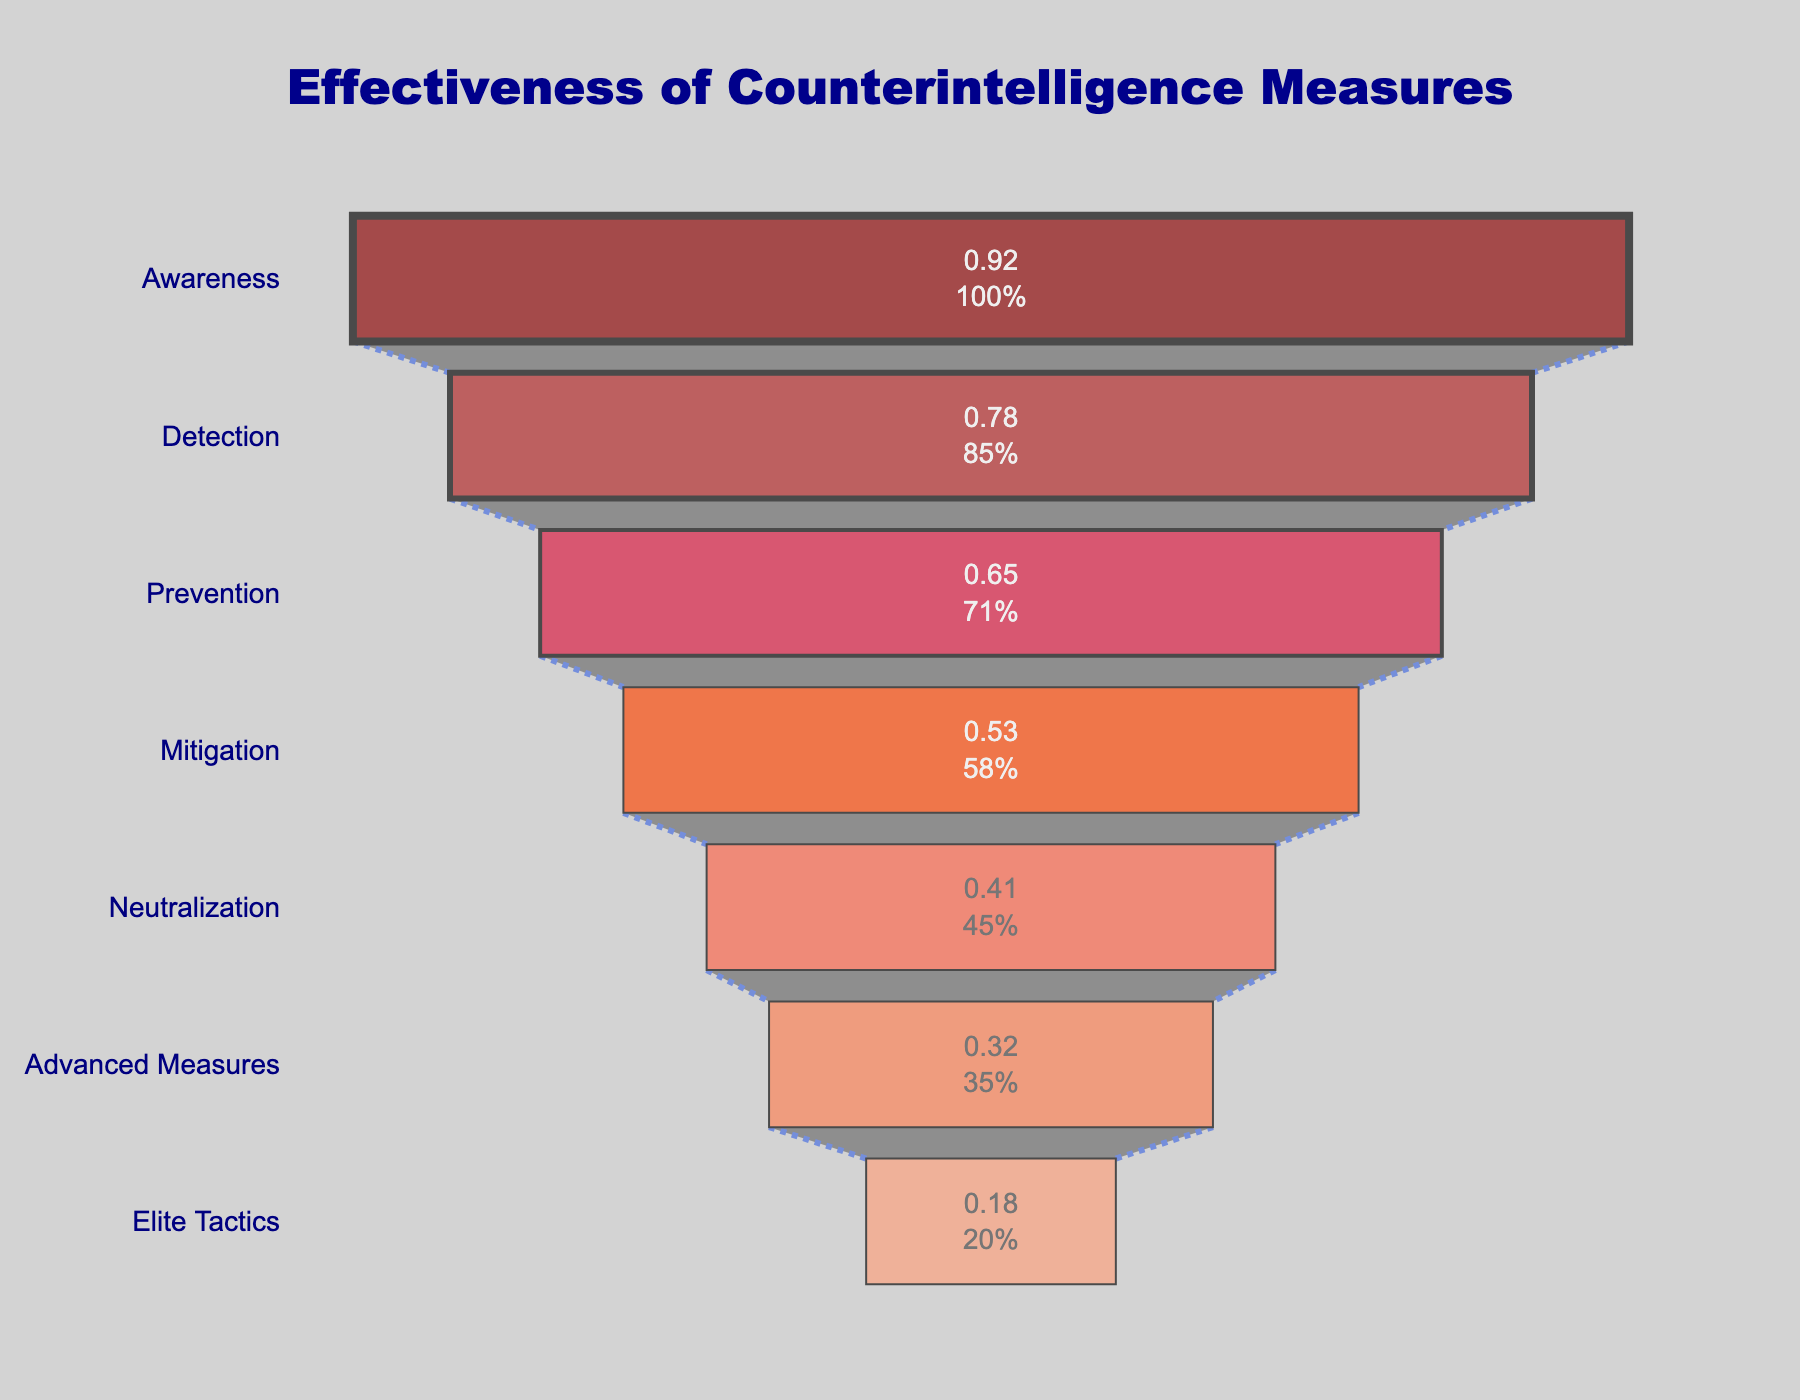What's the title of the figure? The title is the text at the top of the figure, which summarizes what the figure is about. Titles are often positioned centrally at the top of the chart.
Answer: Effectiveness of Counterintelligence Measures Which counterintelligence measure has the lowest effectiveness rate? The effectiveness rate is shown on the horizontal axis, and the one with the smallest value corresponds to the lowest effectiveness. Look for the smallest percentage on the funnel.
Answer: Deep Cover Penetration How many stages are shown in the funnel chart? Count the distinct stages listed on the vertical axis from the top to the bottom of the funnel.
Answer: Seven What is the effectiveness rate of Secure Communication Protocols? Identify the stage labeled "Secure Communication Protocols" and read the effectiveness rate corresponding to it.
Answer: 65% How does the effectiveness rate of Counterintelligence Polygraphs compare to Surveillance Detection Routes? Find the effectiveness rates for both stages and then compare them directly. The rate of Counterintelligence Polygraphs is 53%, and for Surveillance Detection Routes, it is 78%.
Answer: Surveillance Detection Routes have a higher rate What's the average effectiveness rate of the first three stages in the funnel? Identify the effectiveness rates of the first three stages: 92%, 78%, and 65%. Then calculate the average: (92 + 78 + 65)/3.
Answer: 78.33% Which stage shows the largest drop in effectiveness from the previous stage? For each stage, subtract the effectiveness rate of the next stage from its own effectiveness rate. The stage with the largest difference shows the largest drop.
Answer: Secure Communication Protocols to Counterintelligence Polygraphs What can you infer from the color coding of the stages in the funnel? Each stage has a unique color, which helps differentiate them visually. Additionally, the colors might suggest a gradient from most to least effectiveness.
Answer: Colors range from dark red to light peach, indicating decreasing effectiveness What proportion of the initial effectiveness rate does the Mitigation stage have? The initial effectiveness rate is 92%. The Mitigation stage has a 53% effectiveness rate. Divide 53 by 92 and multiply by 100 to get the proportion.
Answer: 57.6% Which two stages show the closest effectiveness rates in the funnel chart? Identify stages with effectiveness rates that have minimal differences by comparing all adjacent stages.
Answer: Prevention (65%) and Mitigation (53%) 